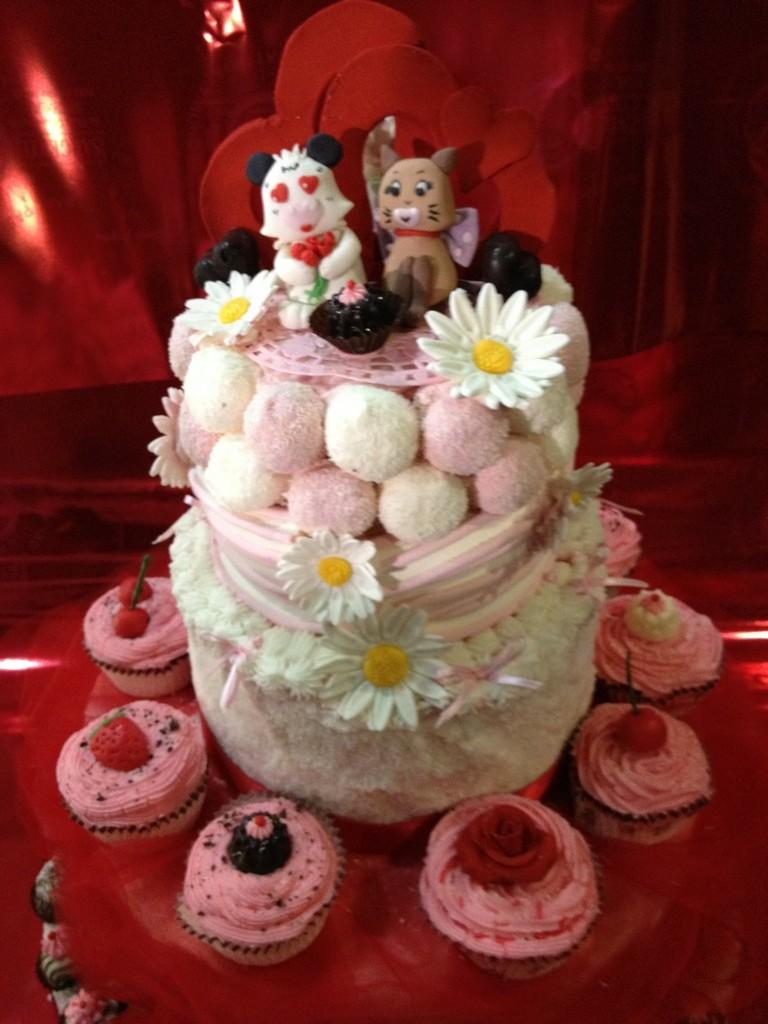What is the main subject of the image? There is a cake in the image. What is unique about the cake? The cake has cupcakes on it. Are there any specific toppings on the cupcakes? Some of the cupcakes are topped with cherries. On what surface is the cake and cupcakes placed? The cake and cupcakes are placed on a surface. Can you tell me how many robins are perched on the cake in the image? There are no robins present in the image; it features a cake with cupcakes and cherries. What type of bear can be seen holding a cupcake in the image? There is no bear present in the image; it only features a cake, cupcakes, and cherries. 